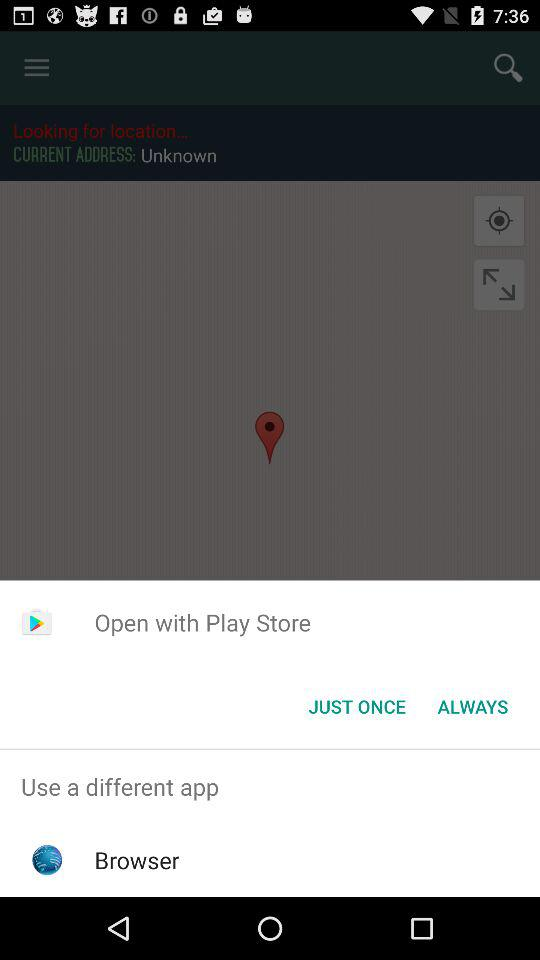How far away is the location?
When the provided information is insufficient, respond with <no answer>. <no answer> 